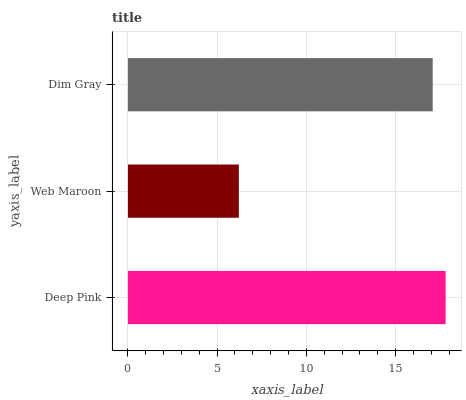Is Web Maroon the minimum?
Answer yes or no. Yes. Is Deep Pink the maximum?
Answer yes or no. Yes. Is Dim Gray the minimum?
Answer yes or no. No. Is Dim Gray the maximum?
Answer yes or no. No. Is Dim Gray greater than Web Maroon?
Answer yes or no. Yes. Is Web Maroon less than Dim Gray?
Answer yes or no. Yes. Is Web Maroon greater than Dim Gray?
Answer yes or no. No. Is Dim Gray less than Web Maroon?
Answer yes or no. No. Is Dim Gray the high median?
Answer yes or no. Yes. Is Dim Gray the low median?
Answer yes or no. Yes. Is Deep Pink the high median?
Answer yes or no. No. Is Deep Pink the low median?
Answer yes or no. No. 